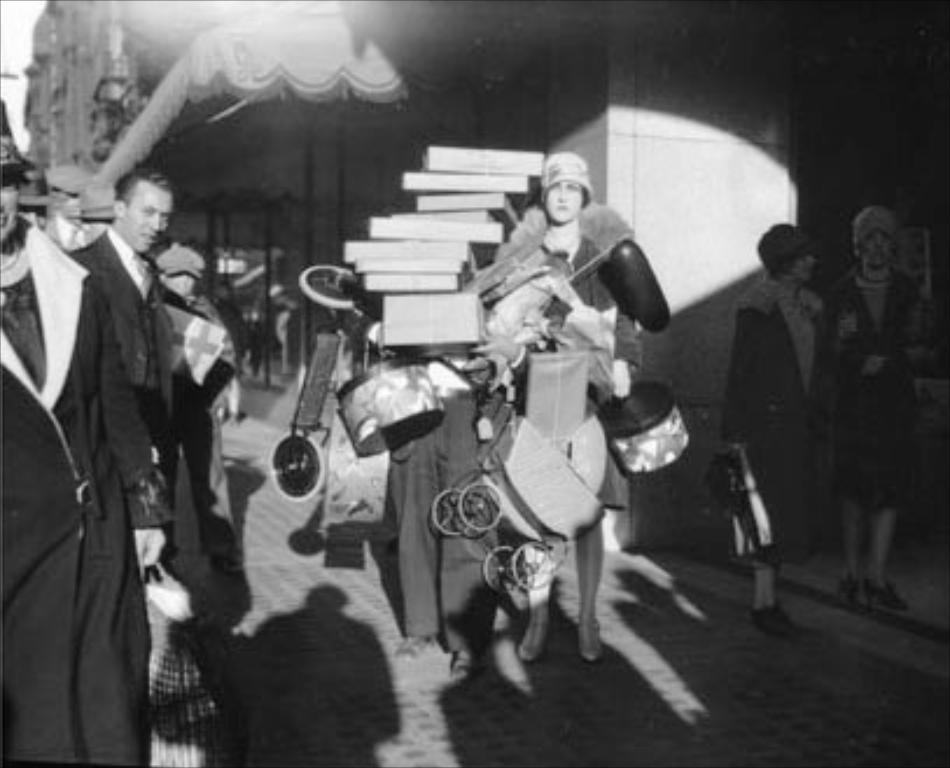How would you summarize this image in a sentence or two? There are persons in different color dresses, some of them are holding musical instruments and books on the footpath near building. Which is having glass windows. In the background, there is sky. 